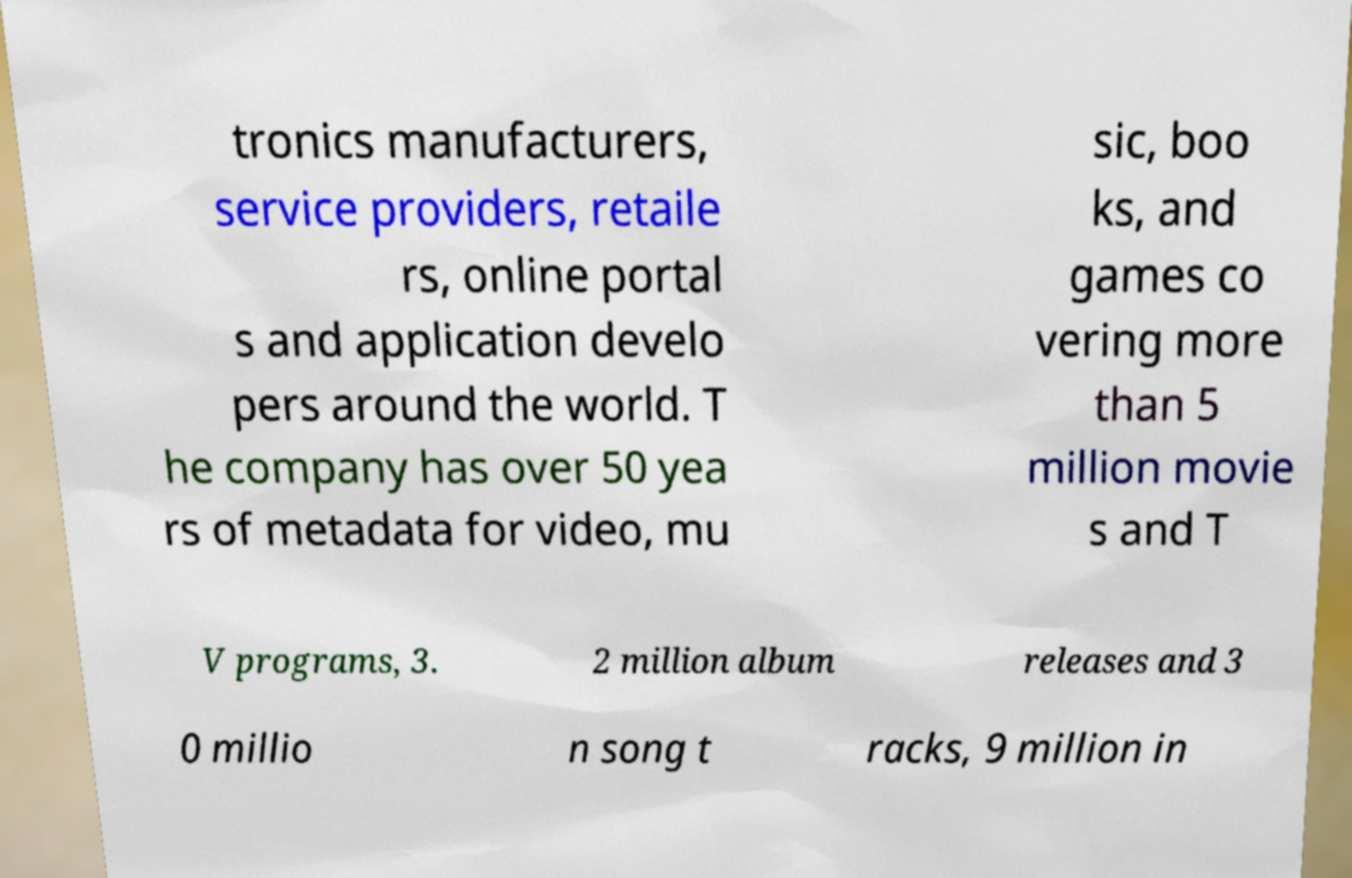Can you accurately transcribe the text from the provided image for me? tronics manufacturers, service providers, retaile rs, online portal s and application develo pers around the world. T he company has over 50 yea rs of metadata for video, mu sic, boo ks, and games co vering more than 5 million movie s and T V programs, 3. 2 million album releases and 3 0 millio n song t racks, 9 million in 